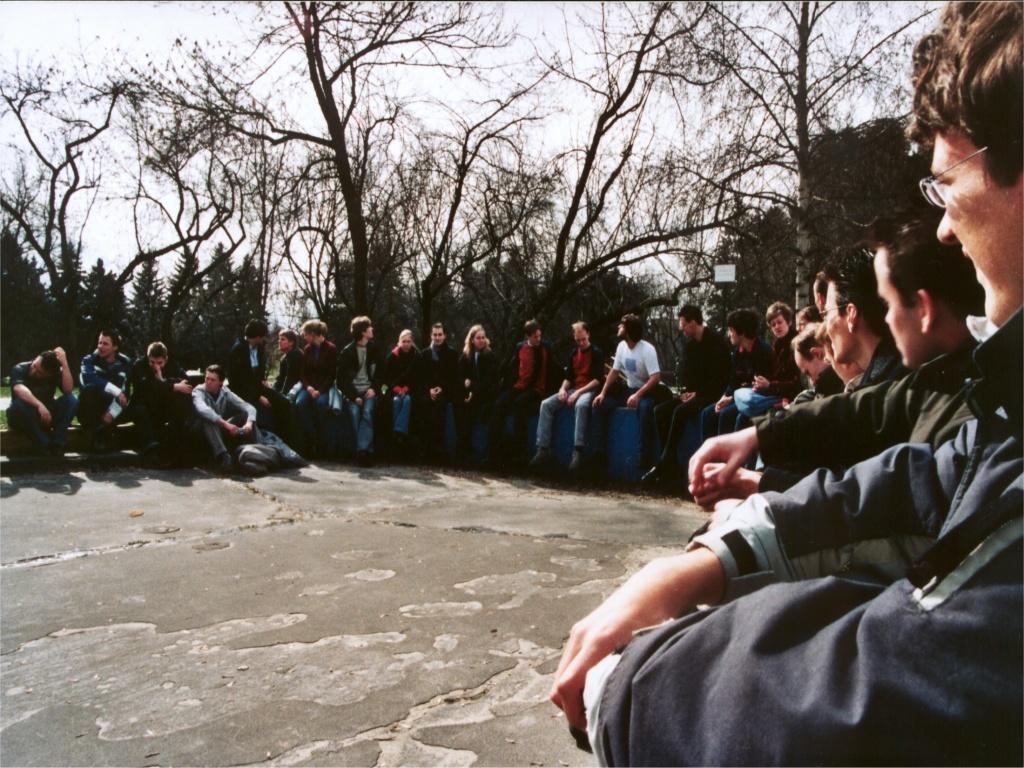Could you give a brief overview of what you see in this image? In this image I can see many people are sitting in a circular way and at the back there are many trees and in the background there is the sky. 